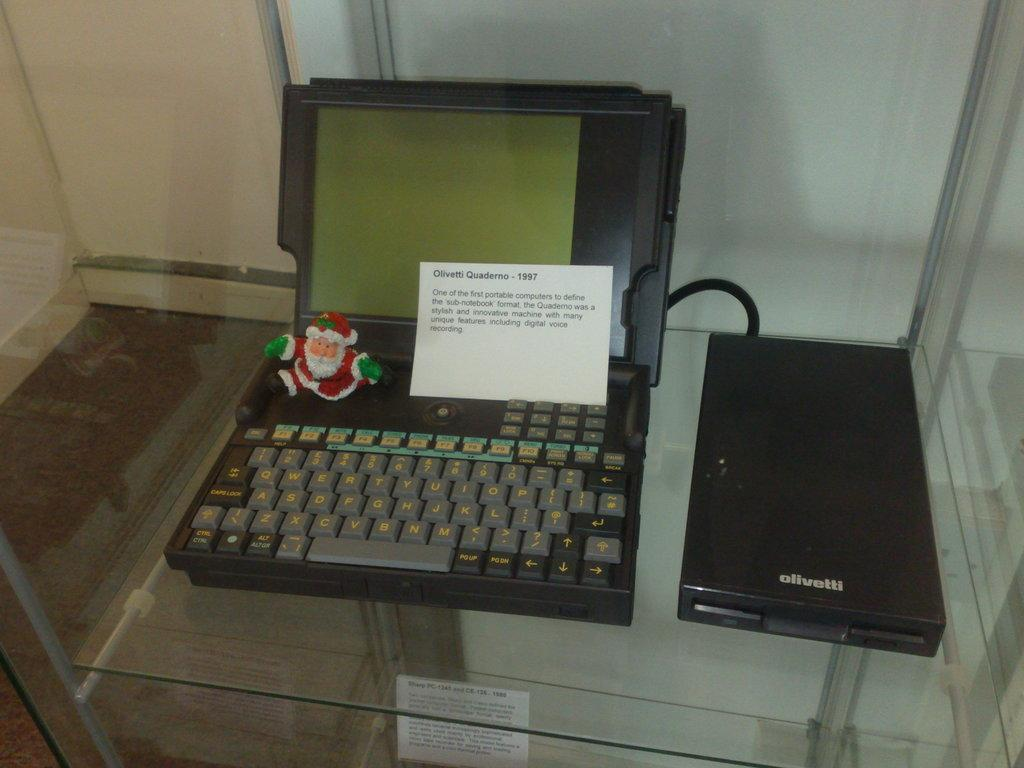Provide a one-sentence caption for the provided image. One of the first sub-notebook Quadermo portable computer. 